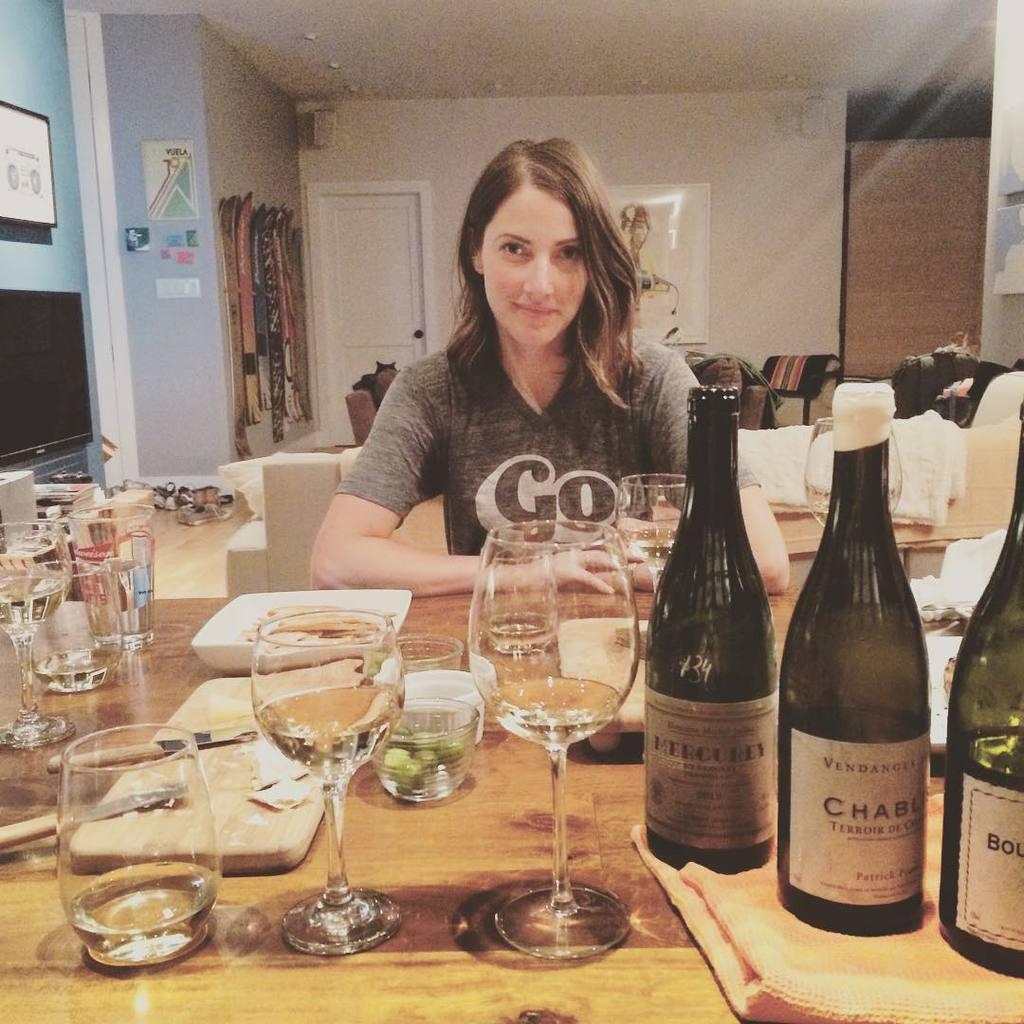What is the brand of wine shown?
Ensure brevity in your answer.  Mercurey. What  is on her shirt?
Your answer should be very brief. Go. 